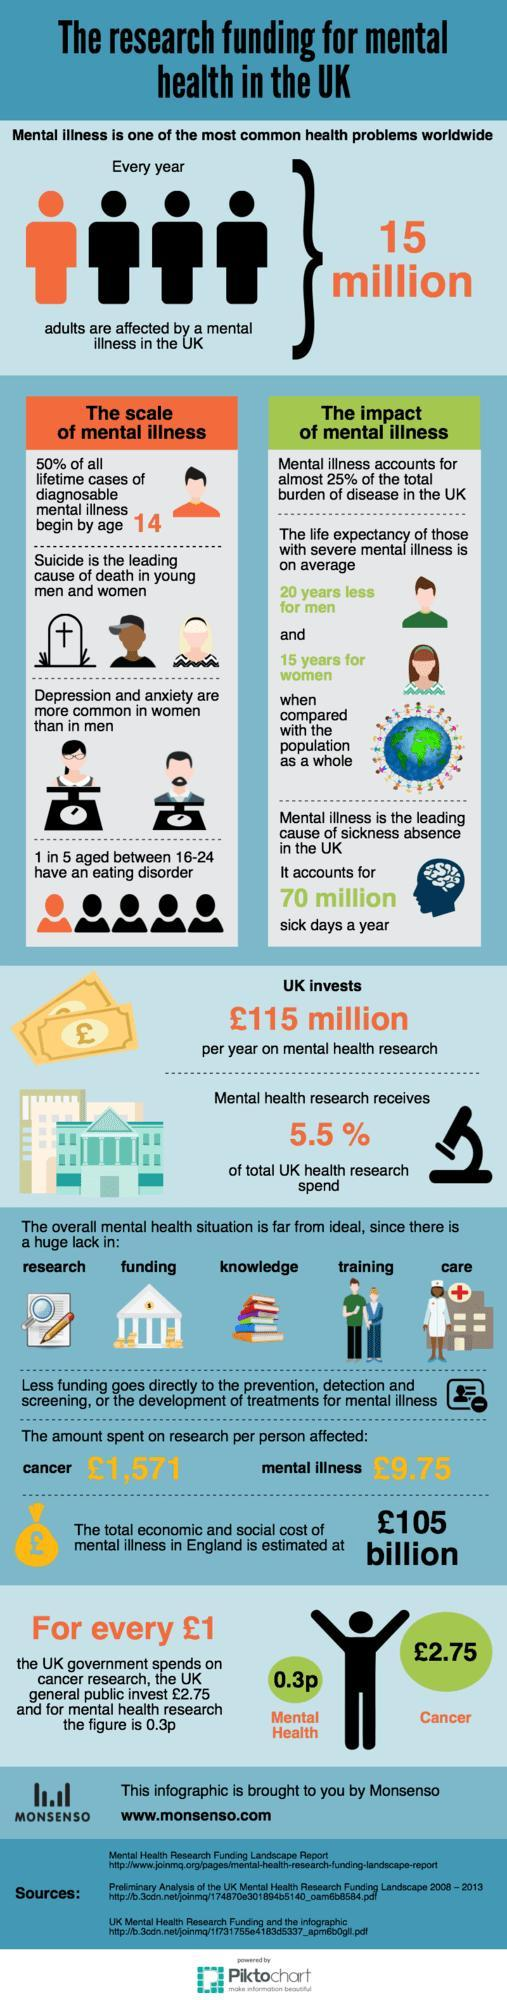Who among the two diagnosed with mental illness have a lower life expectancy, men, or women?
Answer the question with a short phrase. men What is the difference in the amount spent for the research per person for cancer and mental illness? 1,561.25 pounds / person 